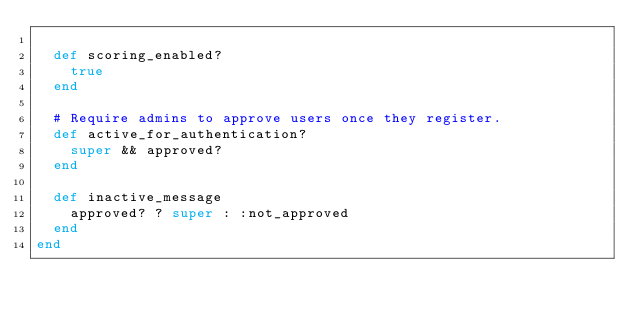Convert code to text. <code><loc_0><loc_0><loc_500><loc_500><_Ruby_>
  def scoring_enabled?
    true
  end

  # Require admins to approve users once they register.
  def active_for_authentication?
    super && approved?
  end

  def inactive_message
    approved? ? super : :not_approved
  end
end
</code> 